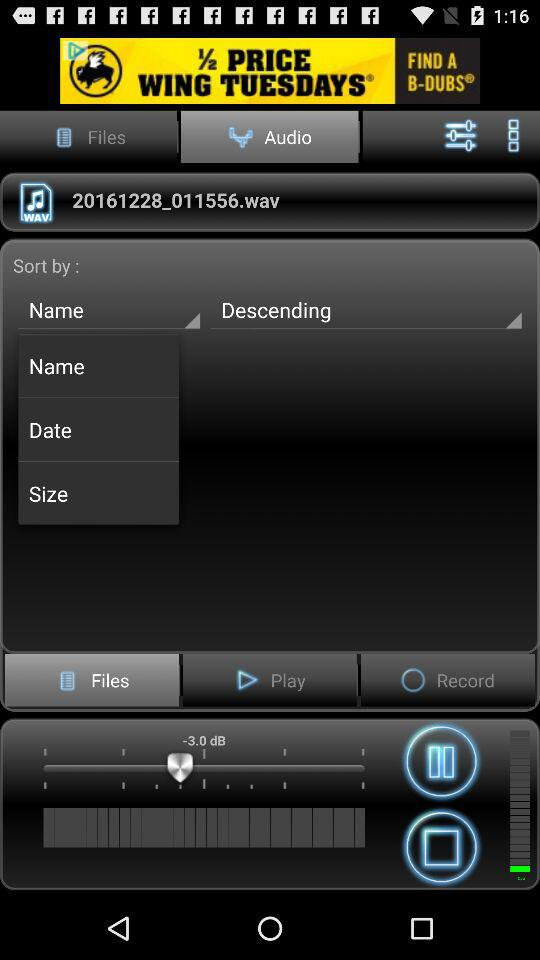Which tab is selected? The selected tab is "Audio". 